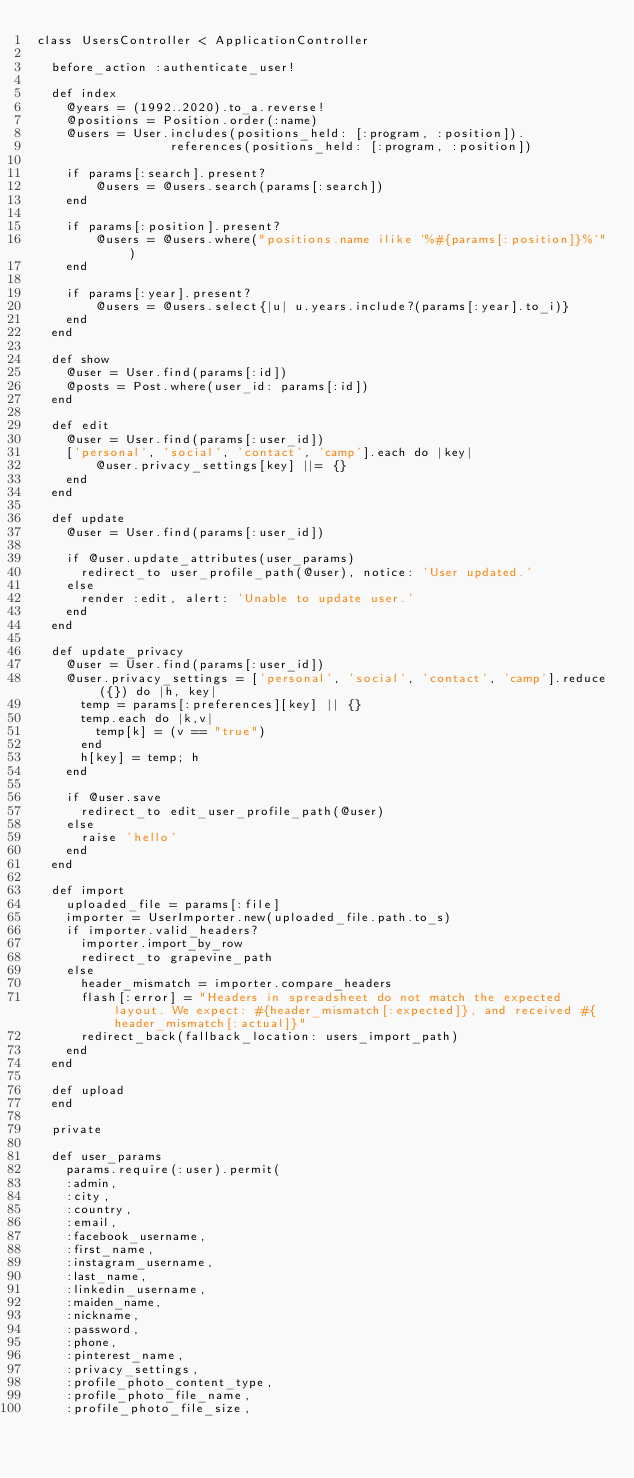<code> <loc_0><loc_0><loc_500><loc_500><_Ruby_>class UsersController < ApplicationController

  before_action :authenticate_user!

  def index
    @years = (1992..2020).to_a.reverse!
    @positions = Position.order(:name)
    @users = User.includes(positions_held: [:program, :position]).
                  references(positions_held: [:program, :position])

    if params[:search].present?
        @users = @users.search(params[:search])
    end

    if params[:position].present?
        @users = @users.where("positions.name ilike '%#{params[:position]}%'")
    end

    if params[:year].present?
        @users = @users.select{|u| u.years.include?(params[:year].to_i)}
    end
  end

  def show
    @user = User.find(params[:id])
    @posts = Post.where(user_id: params[:id])
  end

  def edit
    @user = User.find(params[:user_id])
    ['personal', 'social', 'contact', 'camp'].each do |key|
        @user.privacy_settings[key] ||= {}
    end
  end

  def update
    @user = User.find(params[:user_id])

    if @user.update_attributes(user_params)
      redirect_to user_profile_path(@user), notice: 'User updated.'
    else
      render :edit, alert: 'Unable to update user.'
    end
  end

  def update_privacy
    @user = User.find(params[:user_id])
    @user.privacy_settings = ['personal', 'social', 'contact', 'camp'].reduce({}) do |h, key|
      temp = params[:preferences][key] || {}
      temp.each do |k,v|
        temp[k] = (v == "true")
      end
      h[key] = temp; h
    end

    if @user.save
      redirect_to edit_user_profile_path(@user)
    else
      raise 'hello'
    end
  end

  def import
    uploaded_file = params[:file]
    importer = UserImporter.new(uploaded_file.path.to_s)
    if importer.valid_headers?
      importer.import_by_row
      redirect_to grapevine_path
    else
      header_mismatch = importer.compare_headers
      flash[:error] = "Headers in spreadsheet do not match the expected layout. We expect: #{header_mismatch[:expected]}, and received #{header_mismatch[:actual]}"
      redirect_back(fallback_location: users_import_path)
    end
  end

  def upload
  end

  private

  def user_params
    params.require(:user).permit(
    :admin,
    :city,
    :country,
    :email,
    :facebook_username,
    :first_name,
    :instagram_username,
    :last_name,
    :linkedin_username,
    :maiden_name,
    :nickname,
    :password,
    :phone,
    :pinterest_name,
    :privacy_settings,
    :profile_photo_content_type,
    :profile_photo_file_name,
    :profile_photo_file_size,</code> 